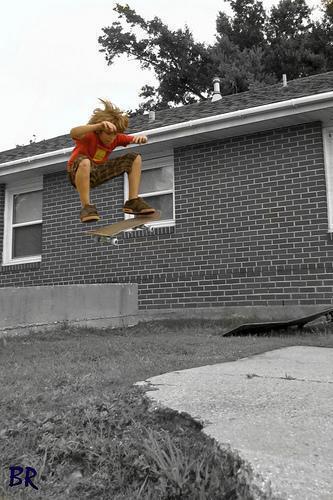How many windows are there?
Give a very brief answer. 2. How many people are pictured?
Give a very brief answer. 1. 